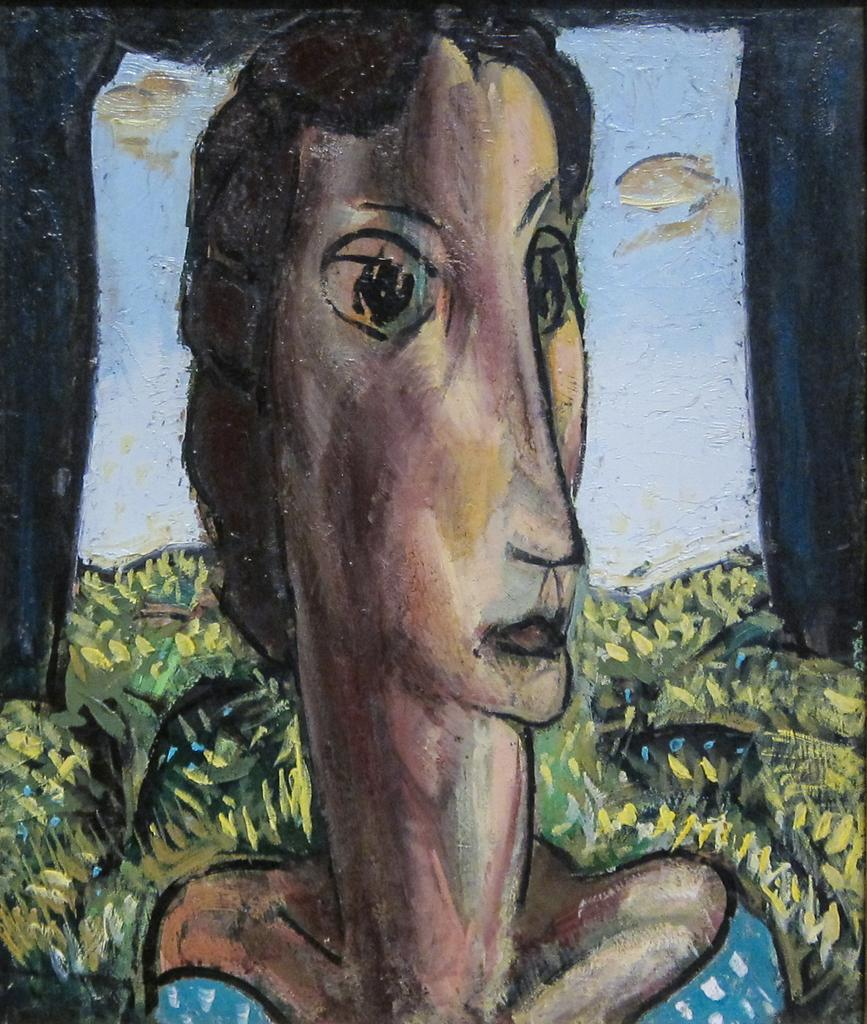What is the main subject of the image? There is a painting in the image. What is depicted in the painting? The painting depicts plants and the face of a person. How many wings can be seen in the painting? There are no wings depicted in the painting; it features plants and a person's face. What type of calendar is shown in the painting? There is no calendar present in the painting; it only includes plants and a person's face. 